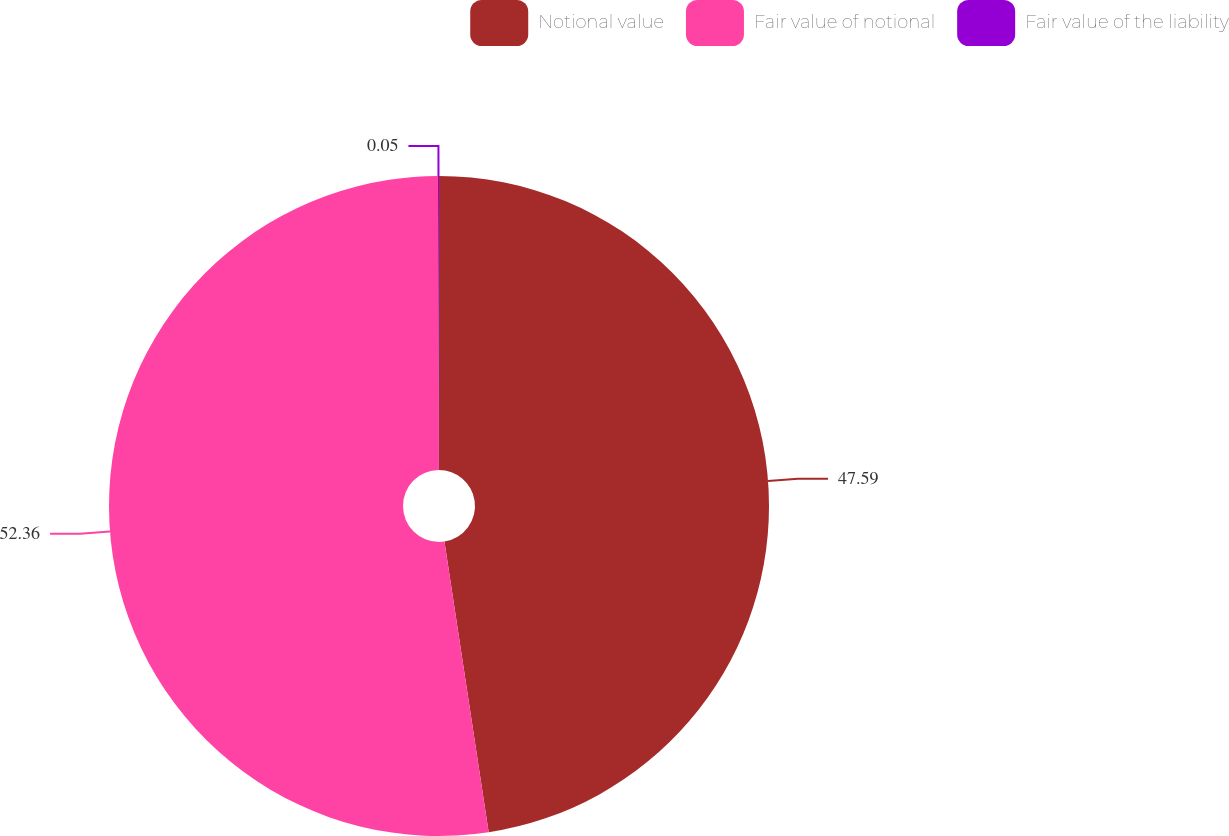Convert chart to OTSL. <chart><loc_0><loc_0><loc_500><loc_500><pie_chart><fcel>Notional value<fcel>Fair value of notional<fcel>Fair value of the liability<nl><fcel>47.59%<fcel>52.35%<fcel>0.05%<nl></chart> 